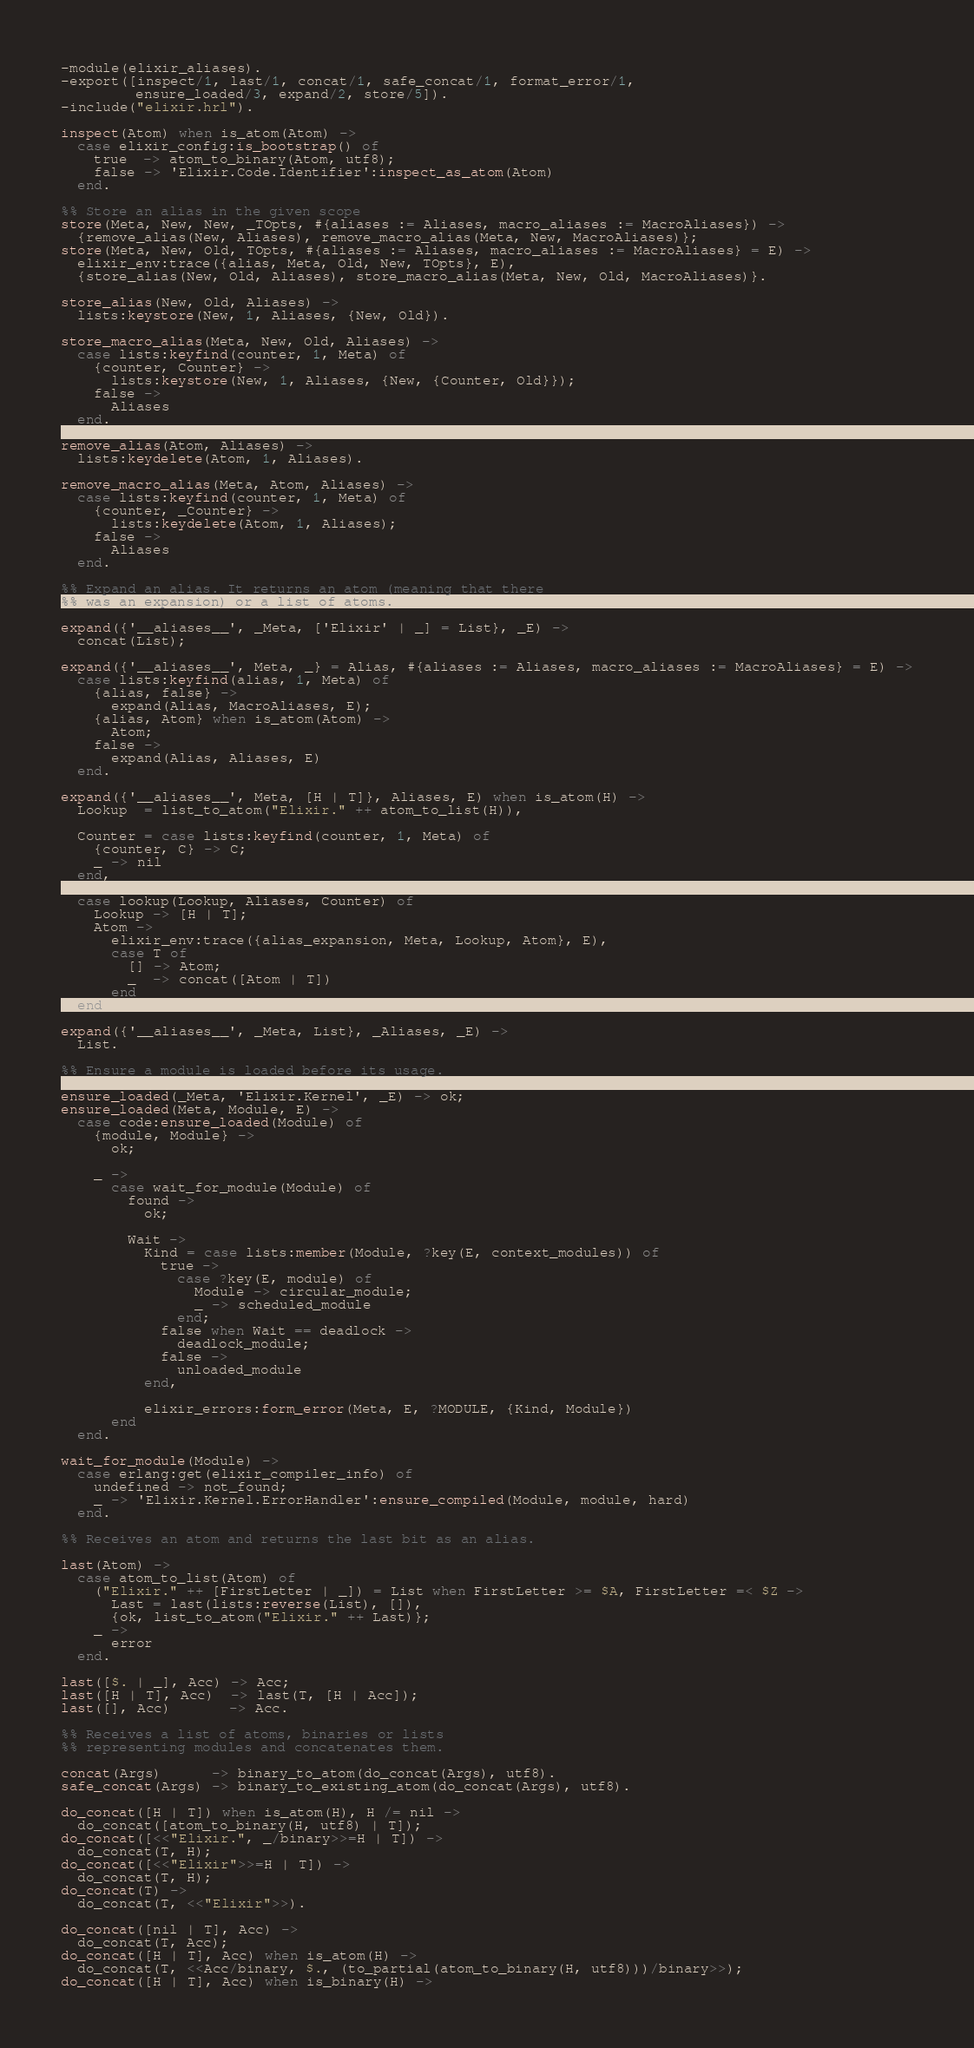Convert code to text. <code><loc_0><loc_0><loc_500><loc_500><_Erlang_>-module(elixir_aliases).
-export([inspect/1, last/1, concat/1, safe_concat/1, format_error/1,
         ensure_loaded/3, expand/2, store/5]).
-include("elixir.hrl").

inspect(Atom) when is_atom(Atom) ->
  case elixir_config:is_bootstrap() of
    true  -> atom_to_binary(Atom, utf8);
    false -> 'Elixir.Code.Identifier':inspect_as_atom(Atom)
  end.

%% Store an alias in the given scope
store(Meta, New, New, _TOpts, #{aliases := Aliases, macro_aliases := MacroAliases}) ->
  {remove_alias(New, Aliases), remove_macro_alias(Meta, New, MacroAliases)};
store(Meta, New, Old, TOpts, #{aliases := Aliases, macro_aliases := MacroAliases} = E) ->
  elixir_env:trace({alias, Meta, Old, New, TOpts}, E),
  {store_alias(New, Old, Aliases), store_macro_alias(Meta, New, Old, MacroAliases)}.

store_alias(New, Old, Aliases) ->
  lists:keystore(New, 1, Aliases, {New, Old}).

store_macro_alias(Meta, New, Old, Aliases) ->
  case lists:keyfind(counter, 1, Meta) of
    {counter, Counter} ->
      lists:keystore(New, 1, Aliases, {New, {Counter, Old}});
    false ->
      Aliases
  end.

remove_alias(Atom, Aliases) ->
  lists:keydelete(Atom, 1, Aliases).

remove_macro_alias(Meta, Atom, Aliases) ->
  case lists:keyfind(counter, 1, Meta) of
    {counter, _Counter} ->
      lists:keydelete(Atom, 1, Aliases);
    false ->
      Aliases
  end.

%% Expand an alias. It returns an atom (meaning that there
%% was an expansion) or a list of atoms.

expand({'__aliases__', _Meta, ['Elixir' | _] = List}, _E) ->
  concat(List);

expand({'__aliases__', Meta, _} = Alias, #{aliases := Aliases, macro_aliases := MacroAliases} = E) ->
  case lists:keyfind(alias, 1, Meta) of
    {alias, false} ->
      expand(Alias, MacroAliases, E);
    {alias, Atom} when is_atom(Atom) ->
      Atom;
    false ->
      expand(Alias, Aliases, E)
  end.

expand({'__aliases__', Meta, [H | T]}, Aliases, E) when is_atom(H) ->
  Lookup  = list_to_atom("Elixir." ++ atom_to_list(H)),

  Counter = case lists:keyfind(counter, 1, Meta) of
    {counter, C} -> C;
    _ -> nil
  end,

  case lookup(Lookup, Aliases, Counter) of
    Lookup -> [H | T];
    Atom ->
      elixir_env:trace({alias_expansion, Meta, Lookup, Atom}, E),
      case T of
        [] -> Atom;
        _  -> concat([Atom | T])
      end
  end;

expand({'__aliases__', _Meta, List}, _Aliases, _E) ->
  List.

%% Ensure a module is loaded before its usage.

ensure_loaded(_Meta, 'Elixir.Kernel', _E) -> ok;
ensure_loaded(Meta, Module, E) ->
  case code:ensure_loaded(Module) of
    {module, Module} ->
      ok;

    _ ->
      case wait_for_module(Module) of
        found ->
          ok;

        Wait ->
          Kind = case lists:member(Module, ?key(E, context_modules)) of
            true ->
              case ?key(E, module) of
                Module -> circular_module;
                _ -> scheduled_module
              end;
            false when Wait == deadlock ->
              deadlock_module;
            false ->
              unloaded_module
          end,

          elixir_errors:form_error(Meta, E, ?MODULE, {Kind, Module})
      end
  end.

wait_for_module(Module) ->
  case erlang:get(elixir_compiler_info) of
    undefined -> not_found;
    _ -> 'Elixir.Kernel.ErrorHandler':ensure_compiled(Module, module, hard)
  end.

%% Receives an atom and returns the last bit as an alias.

last(Atom) ->
  case atom_to_list(Atom) of
    ("Elixir." ++ [FirstLetter | _]) = List when FirstLetter >= $A, FirstLetter =< $Z ->
      Last = last(lists:reverse(List), []),
      {ok, list_to_atom("Elixir." ++ Last)};
    _ ->
      error
  end.

last([$. | _], Acc) -> Acc;
last([H | T], Acc)  -> last(T, [H | Acc]);
last([], Acc)       -> Acc.

%% Receives a list of atoms, binaries or lists
%% representing modules and concatenates them.

concat(Args)      -> binary_to_atom(do_concat(Args), utf8).
safe_concat(Args) -> binary_to_existing_atom(do_concat(Args), utf8).

do_concat([H | T]) when is_atom(H), H /= nil ->
  do_concat([atom_to_binary(H, utf8) | T]);
do_concat([<<"Elixir.", _/binary>>=H | T]) ->
  do_concat(T, H);
do_concat([<<"Elixir">>=H | T]) ->
  do_concat(T, H);
do_concat(T) ->
  do_concat(T, <<"Elixir">>).

do_concat([nil | T], Acc) ->
  do_concat(T, Acc);
do_concat([H | T], Acc) when is_atom(H) ->
  do_concat(T, <<Acc/binary, $., (to_partial(atom_to_binary(H, utf8)))/binary>>);
do_concat([H | T], Acc) when is_binary(H) -></code> 